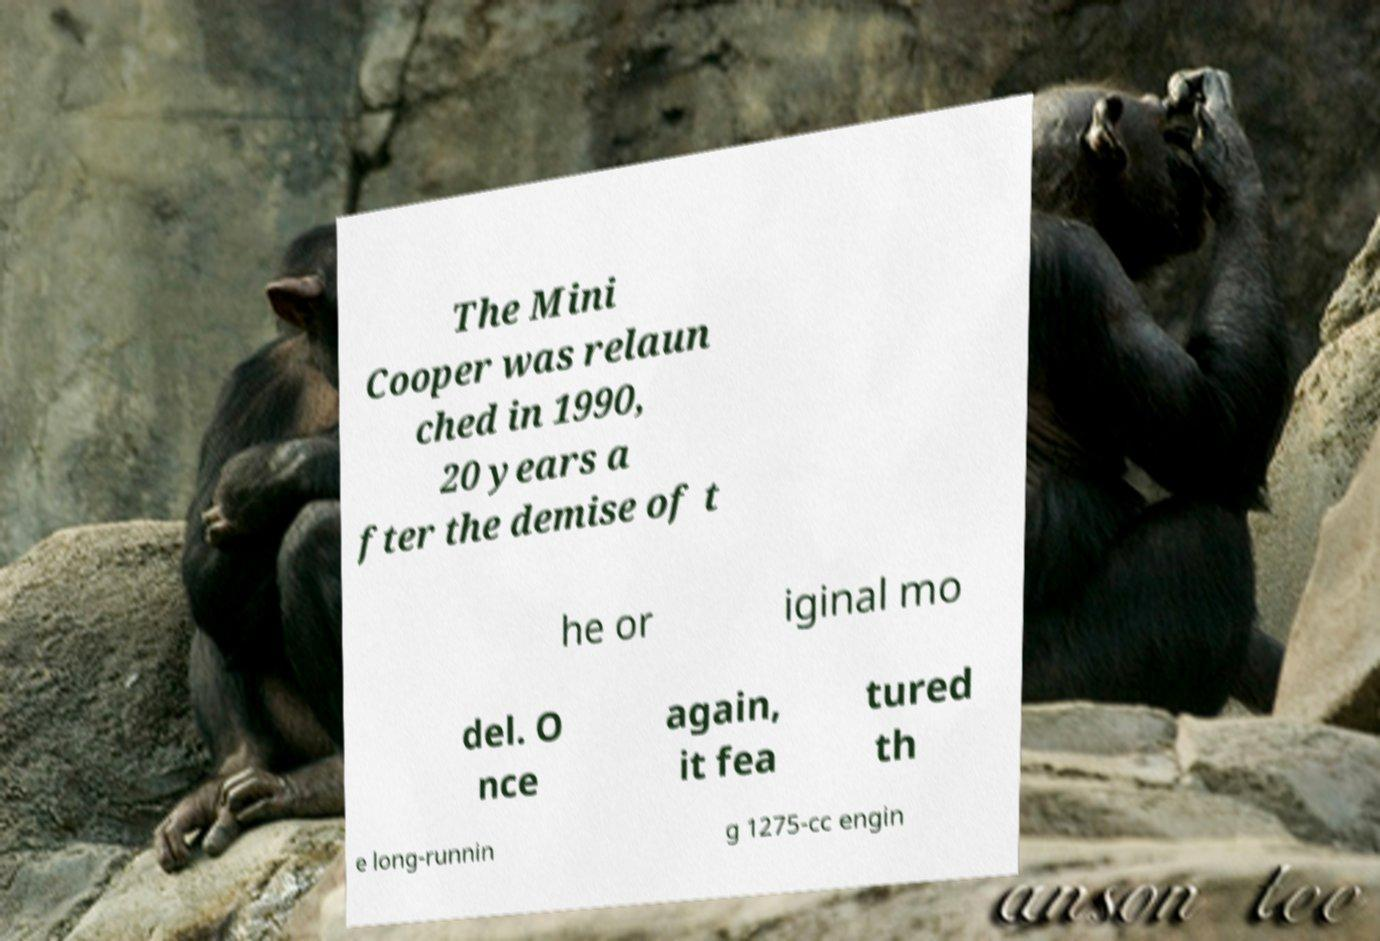Please read and relay the text visible in this image. What does it say? The Mini Cooper was relaun ched in 1990, 20 years a fter the demise of t he or iginal mo del. O nce again, it fea tured th e long-runnin g 1275-cc engin 